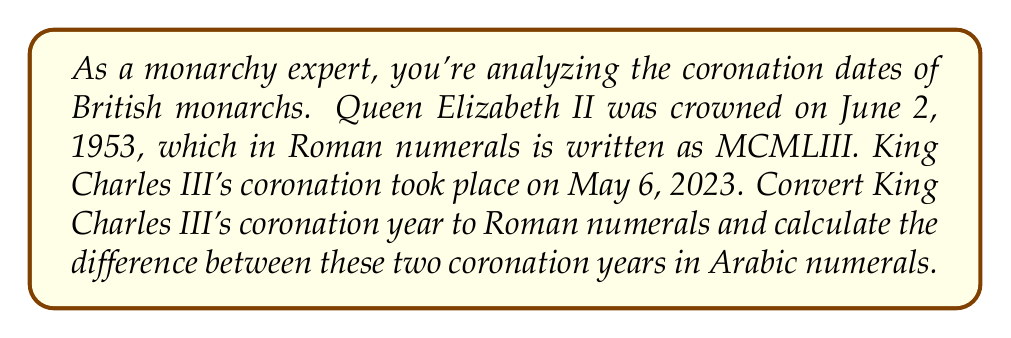Could you help me with this problem? To solve this problem, we need to follow these steps:

1. Convert 2023 to Roman numerals:
   - 2000 = MM
   - 20 = XX
   - 3 = III
   Therefore, 2023 in Roman numerals is MMXXIII

2. Now we have both coronation years in Roman numerals:
   - Elizabeth II: MCMLIII (1953)
   - Charles III: MMXXIII (2023)

3. To calculate the difference, we need to convert both years back to Arabic numerals:
   - MCMLIII = 1000 + 900 + 50 + 3 = 1953
   - MMXXIII = 2000 + 20 + 3 = 2023

4. Calculate the difference:
   $2023 - 1953 = 70$

The difference between the two coronation years is 70 years.
Answer: King Charles III's coronation year in Roman numerals: MMXXIII
Difference between coronation years: 70 years 